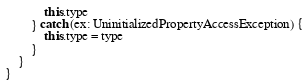Convert code to text. <code><loc_0><loc_0><loc_500><loc_500><_Kotlin_>            this.type
        } catch (ex: UninitializedPropertyAccessException) {
            this.type = type
        }
    }
}</code> 